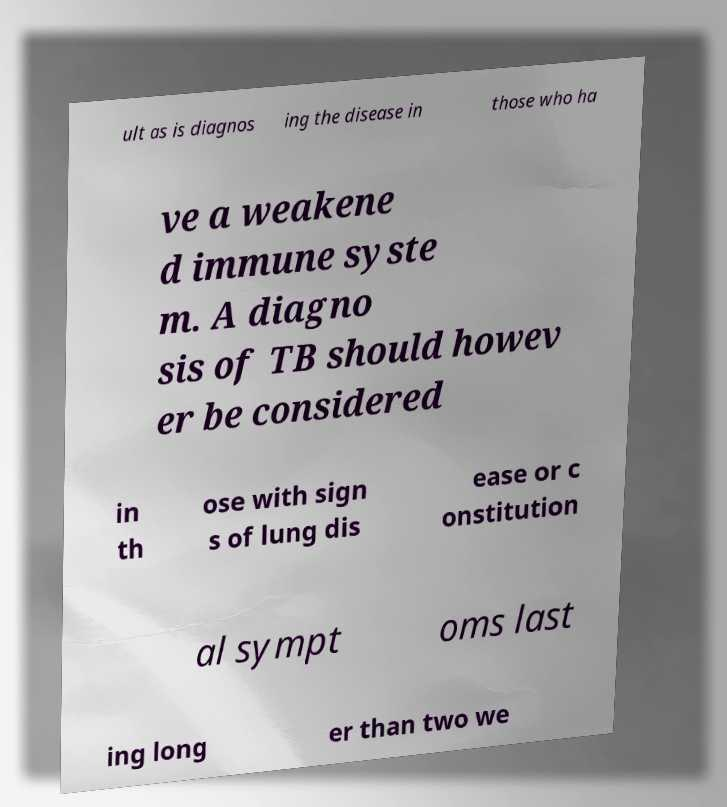Can you accurately transcribe the text from the provided image for me? ult as is diagnos ing the disease in those who ha ve a weakene d immune syste m. A diagno sis of TB should howev er be considered in th ose with sign s of lung dis ease or c onstitution al sympt oms last ing long er than two we 